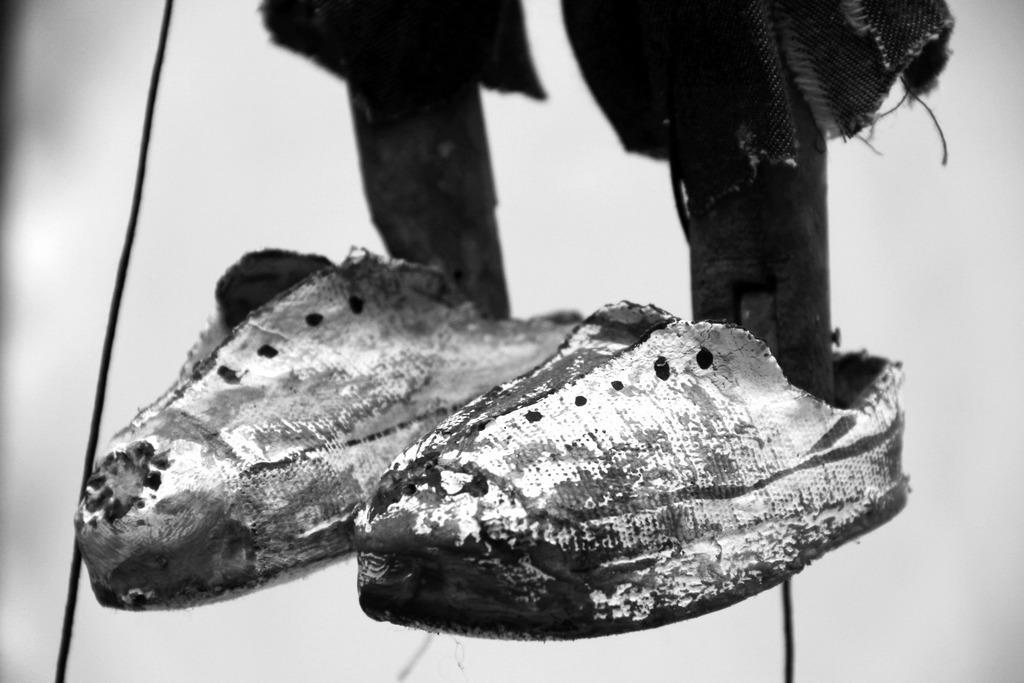Please provide a concise description of this image. This picture is a black and white image. In this image we can see two shoes with wooden poles in it, two black wires, some cloth attached to these poles, one nail on the right side pole and there is a white background. 